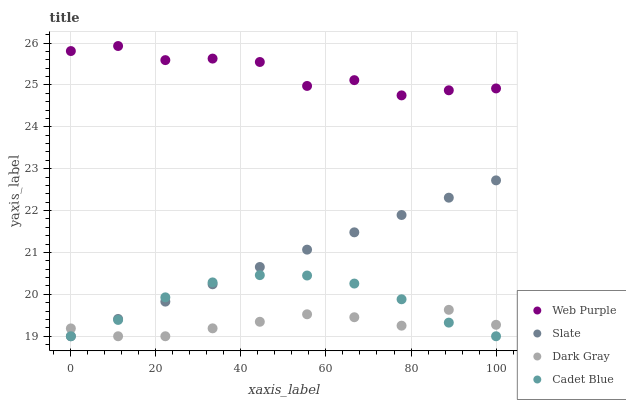Does Dark Gray have the minimum area under the curve?
Answer yes or no. Yes. Does Web Purple have the maximum area under the curve?
Answer yes or no. Yes. Does Cadet Blue have the minimum area under the curve?
Answer yes or no. No. Does Cadet Blue have the maximum area under the curve?
Answer yes or no. No. Is Slate the smoothest?
Answer yes or no. Yes. Is Web Purple the roughest?
Answer yes or no. Yes. Is Cadet Blue the smoothest?
Answer yes or no. No. Is Cadet Blue the roughest?
Answer yes or no. No. Does Dark Gray have the lowest value?
Answer yes or no. Yes. Does Web Purple have the lowest value?
Answer yes or no. No. Does Web Purple have the highest value?
Answer yes or no. Yes. Does Cadet Blue have the highest value?
Answer yes or no. No. Is Dark Gray less than Web Purple?
Answer yes or no. Yes. Is Web Purple greater than Cadet Blue?
Answer yes or no. Yes. Does Slate intersect Dark Gray?
Answer yes or no. Yes. Is Slate less than Dark Gray?
Answer yes or no. No. Is Slate greater than Dark Gray?
Answer yes or no. No. Does Dark Gray intersect Web Purple?
Answer yes or no. No. 